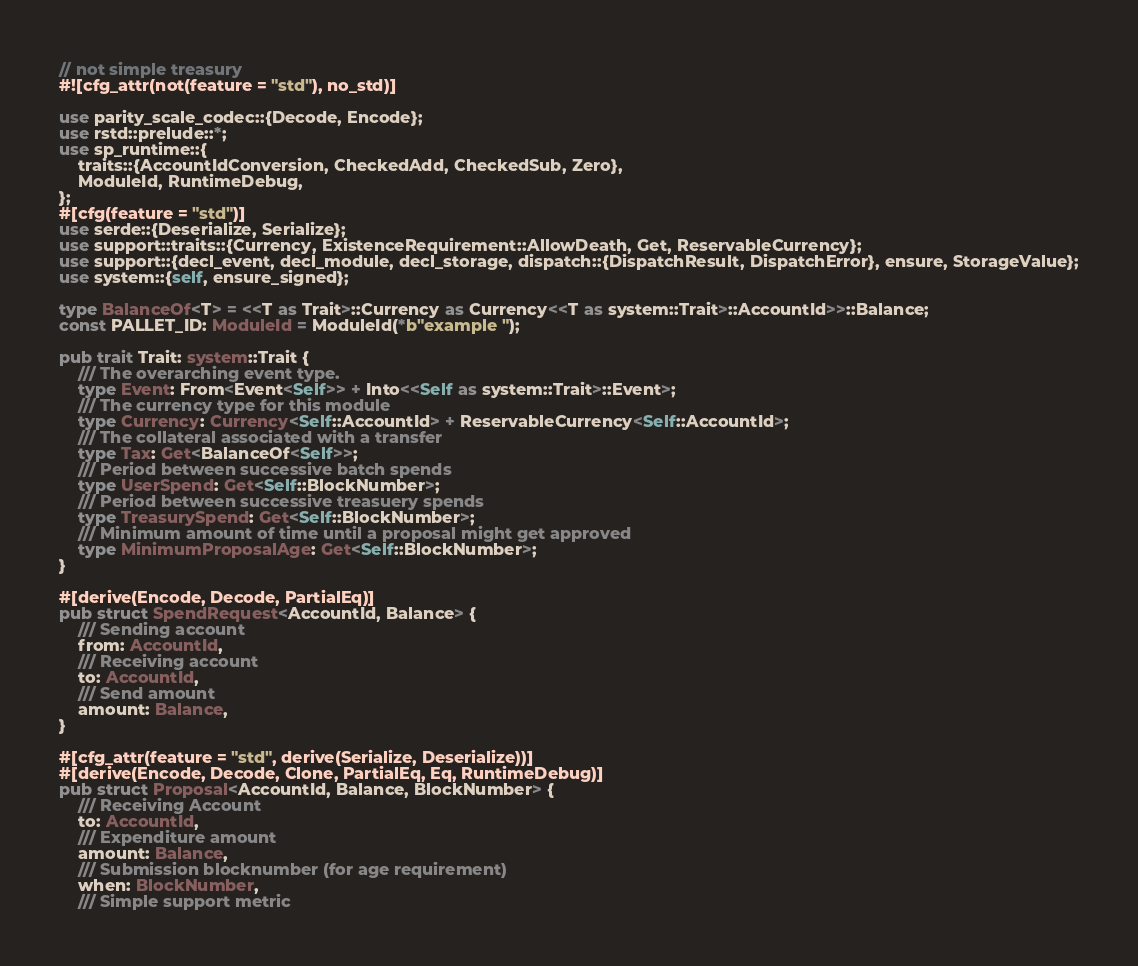<code> <loc_0><loc_0><loc_500><loc_500><_Rust_>// not simple treasury
#![cfg_attr(not(feature = "std"), no_std)]

use parity_scale_codec::{Decode, Encode};
use rstd::prelude::*;
use sp_runtime::{
    traits::{AccountIdConversion, CheckedAdd, CheckedSub, Zero},
    ModuleId, RuntimeDebug,
};
#[cfg(feature = "std")]
use serde::{Deserialize, Serialize};
use support::traits::{Currency, ExistenceRequirement::AllowDeath, Get, ReservableCurrency};
use support::{decl_event, decl_module, decl_storage, dispatch::{DispatchResult, DispatchError}, ensure, StorageValue};
use system::{self, ensure_signed};

type BalanceOf<T> = <<T as Trait>::Currency as Currency<<T as system::Trait>::AccountId>>::Balance;
const PALLET_ID: ModuleId = ModuleId(*b"example ");

pub trait Trait: system::Trait {
    /// The overarching event type.
    type Event: From<Event<Self>> + Into<<Self as system::Trait>::Event>;
    /// The currency type for this module
    type Currency: Currency<Self::AccountId> + ReservableCurrency<Self::AccountId>;
    /// The collateral associated with a transfer
    type Tax: Get<BalanceOf<Self>>;
    /// Period between successive batch spends
    type UserSpend: Get<Self::BlockNumber>;
    /// Period between successive treasuery spends
    type TreasurySpend: Get<Self::BlockNumber>;
    /// Minimum amount of time until a proposal might get approved
    type MinimumProposalAge: Get<Self::BlockNumber>;
}

#[derive(Encode, Decode, PartialEq)]
pub struct SpendRequest<AccountId, Balance> {
    /// Sending account
    from: AccountId,
    /// Receiving account
    to: AccountId,
    /// Send amount
    amount: Balance,
}

#[cfg_attr(feature = "std", derive(Serialize, Deserialize))]
#[derive(Encode, Decode, Clone, PartialEq, Eq, RuntimeDebug)]
pub struct Proposal<AccountId, Balance, BlockNumber> {
    /// Receiving Account
    to: AccountId,
    /// Expenditure amount
    amount: Balance,
    /// Submission blocknumber (for age requirement)
    when: BlockNumber,
    /// Simple support metric</code> 